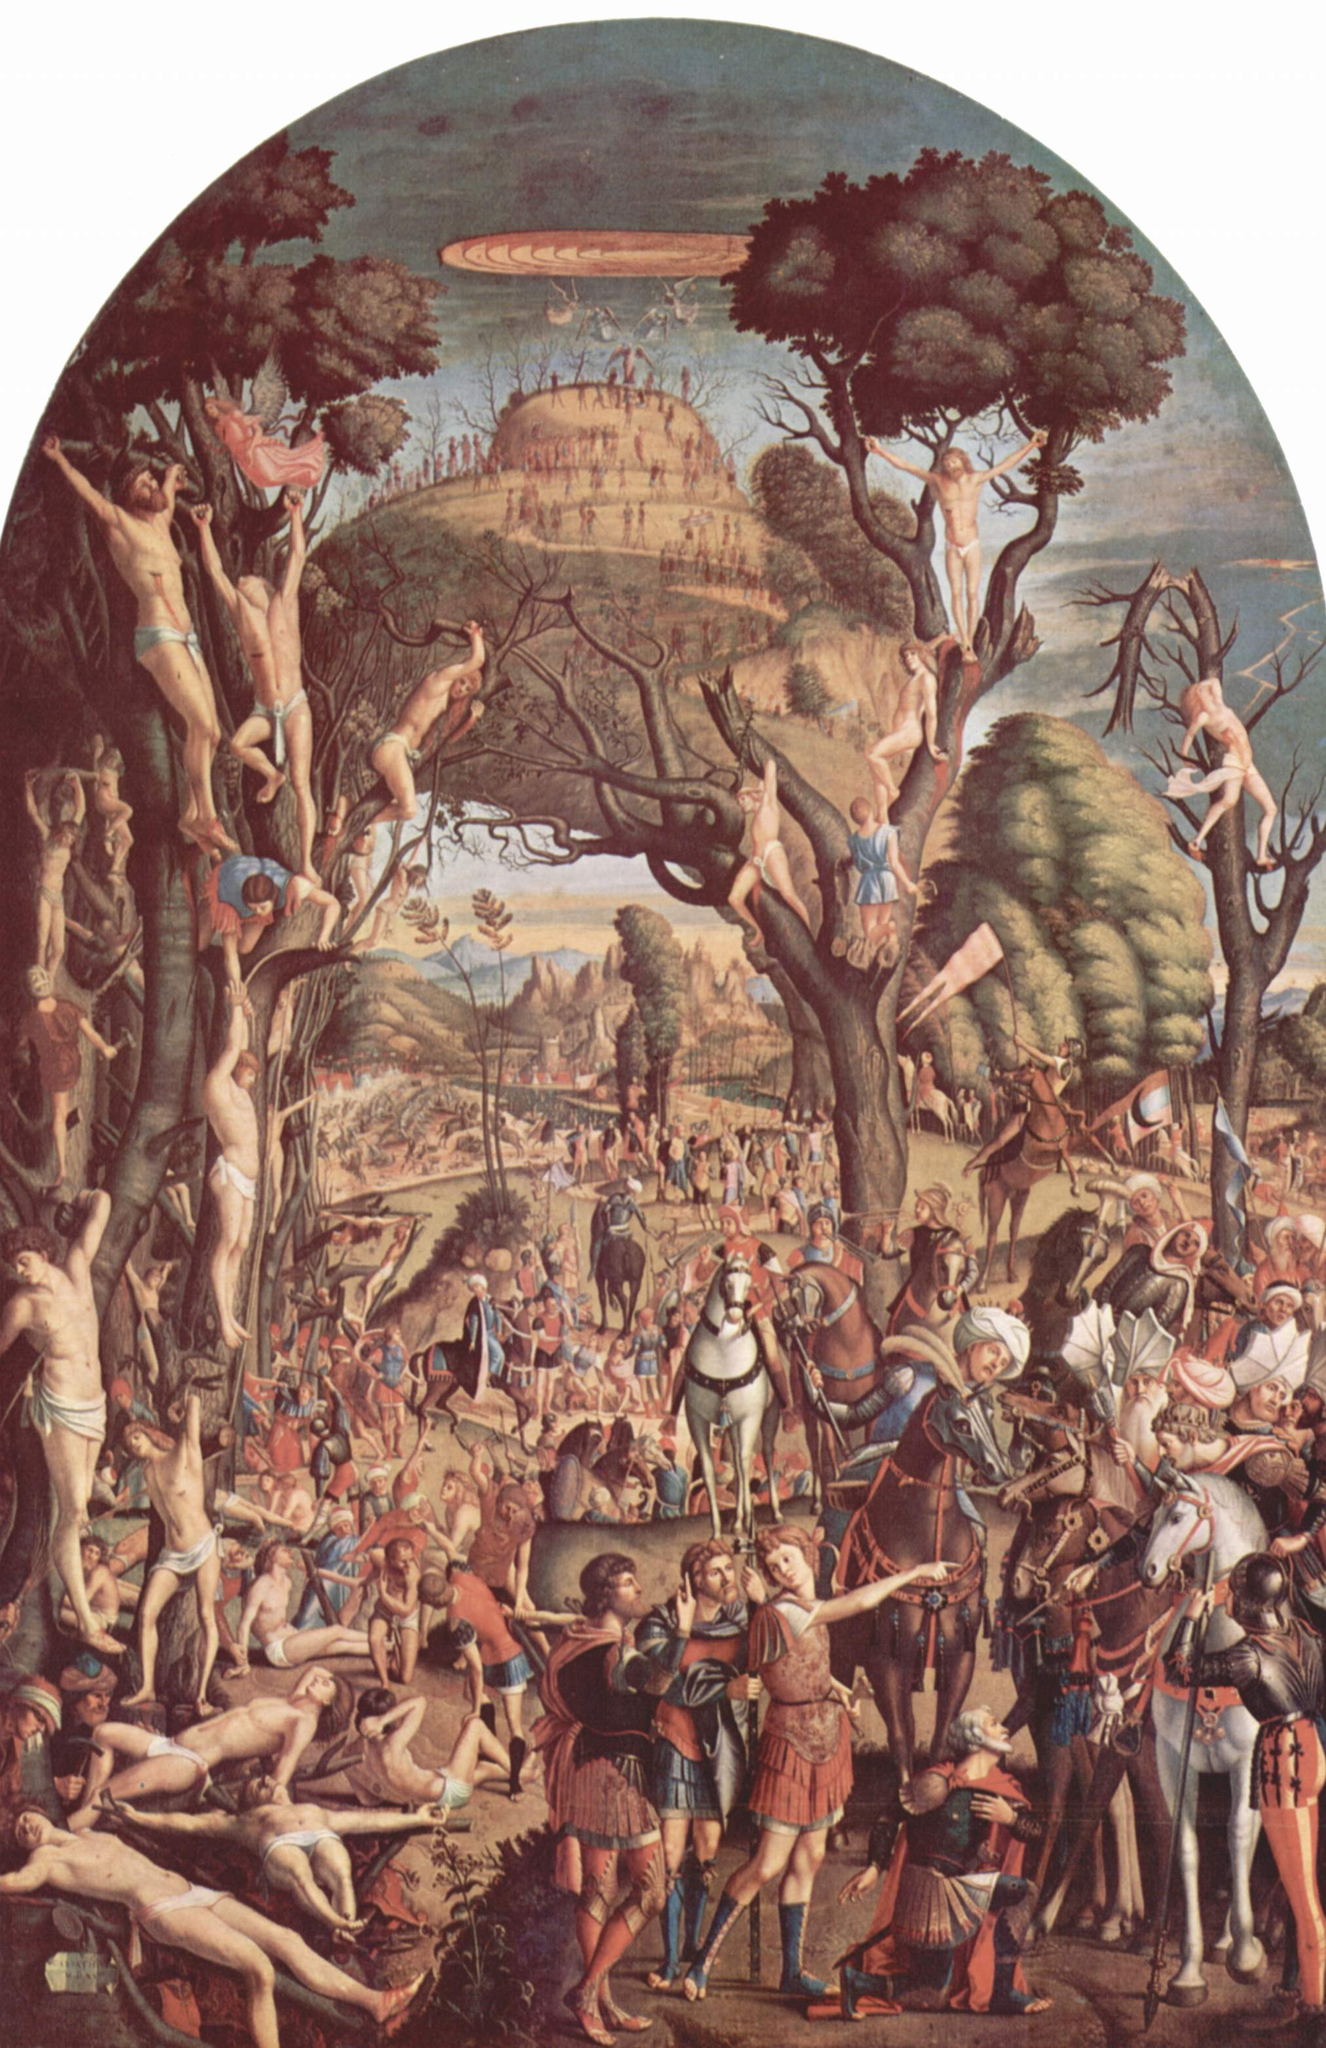What are the key elements in this picture? This image is a striking example of the Mannerist style from the Renaissance period, characterized by its dramatic and surreal qualities. In the foreground, the painting portrays a group of nude figures, their bodies elongated and posed in exaggerated forms that lend a sense of dynamic movement and tension. These figures are intertwined with the gnarled tree branches, creating a lively scene that contrasts sharply with the somber group of soldiers and a knight on horseback depicted below, who are dressed in period-specific armor and attire, adding a layer of historical narrative to the piece. The background further complements this juxtaposition with a tranquil landscape featuring a winding river leading to a distant city, perhaps suggesting the inevitable connection between nature and human endeavors. This complex layering of themes and styles embodies the explorative spirit of the Renaissance, pushing the boundaries of artistic expression. 